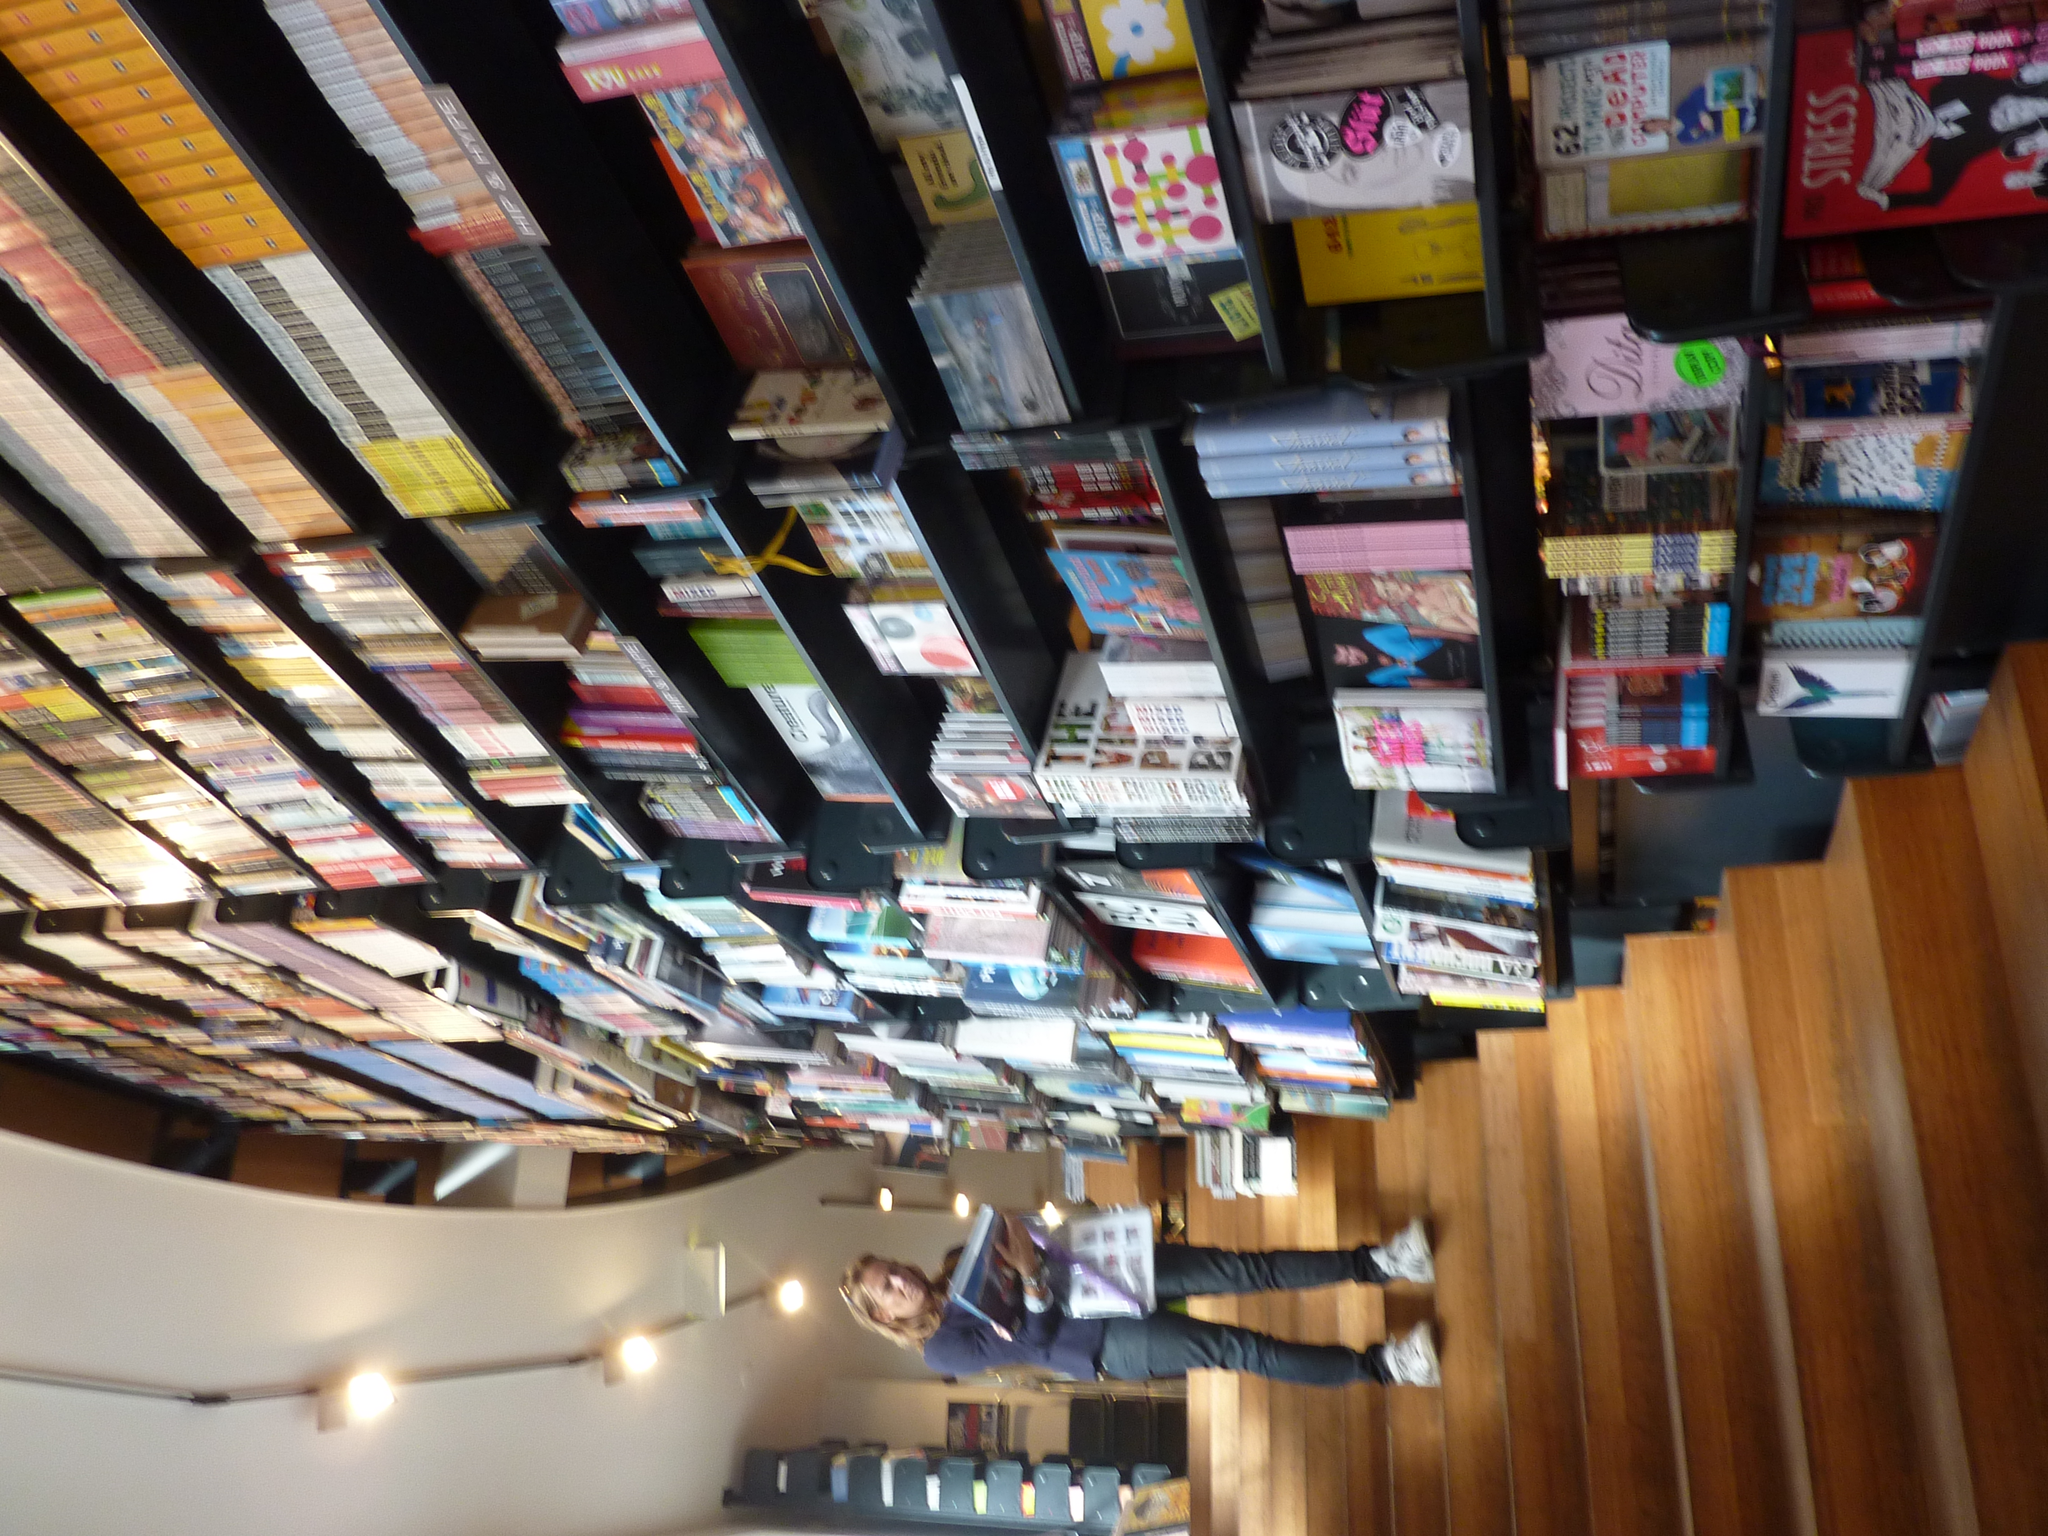Please provide a concise description of this image. At the bottom of the image we can see a lady standing on the stairs. She is holding some books before her there is a shelf and we can see many books placed in the shelf and there are lights. 